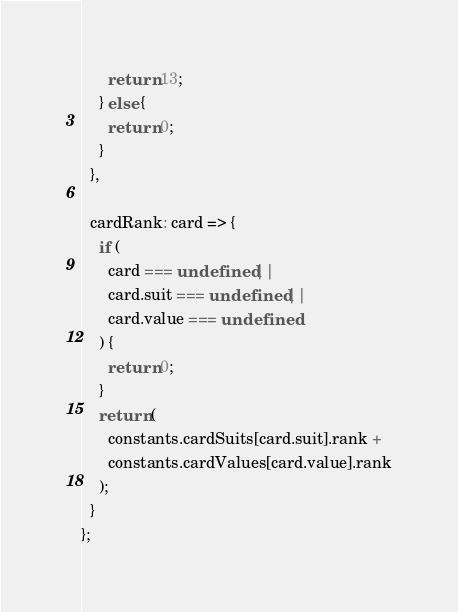Convert code to text. <code><loc_0><loc_0><loc_500><loc_500><_JavaScript_>      return 13;
    } else {
      return 0;
    }
  },

  cardRank: card => {
    if (
      card === undefined ||
      card.suit === undefined ||
      card.value === undefined
    ) {
      return 0;
    }
    return (
      constants.cardSuits[card.suit].rank +
      constants.cardValues[card.value].rank
    );
  }
};
</code> 